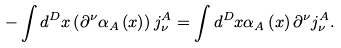Convert formula to latex. <formula><loc_0><loc_0><loc_500><loc_500>- \int d ^ { D } x \left ( \partial ^ { \nu } \alpha _ { A } \left ( x \right ) \right ) j _ { \nu } ^ { A } = \int d ^ { D } x \alpha _ { A } \left ( x \right ) \partial ^ { \nu } j _ { \nu } ^ { A } .</formula> 